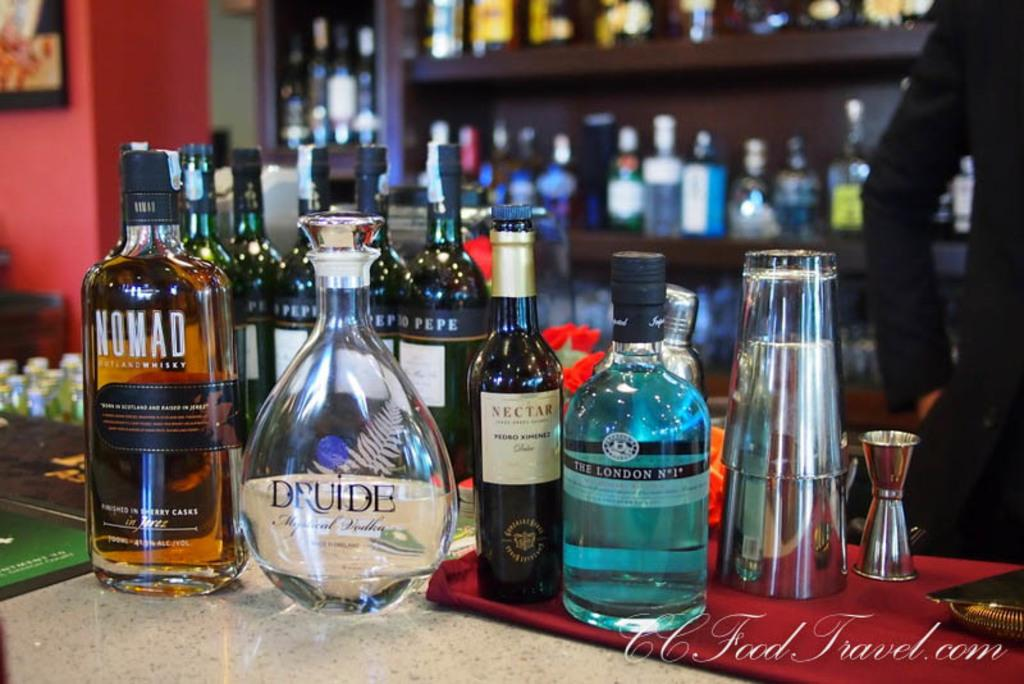<image>
Summarize the visual content of the image. A selection of liquors at a bar includes a bottle of Nomad whiskey. 